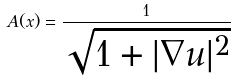<formula> <loc_0><loc_0><loc_500><loc_500>A ( x ) = \frac { 1 } { \sqrt { 1 + | \nabla u | ^ { 2 } } }</formula> 